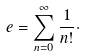Convert formula to latex. <formula><loc_0><loc_0><loc_500><loc_500>e = \sum _ { n = 0 } ^ { \infty } \frac { 1 } { n ! } \cdot</formula> 